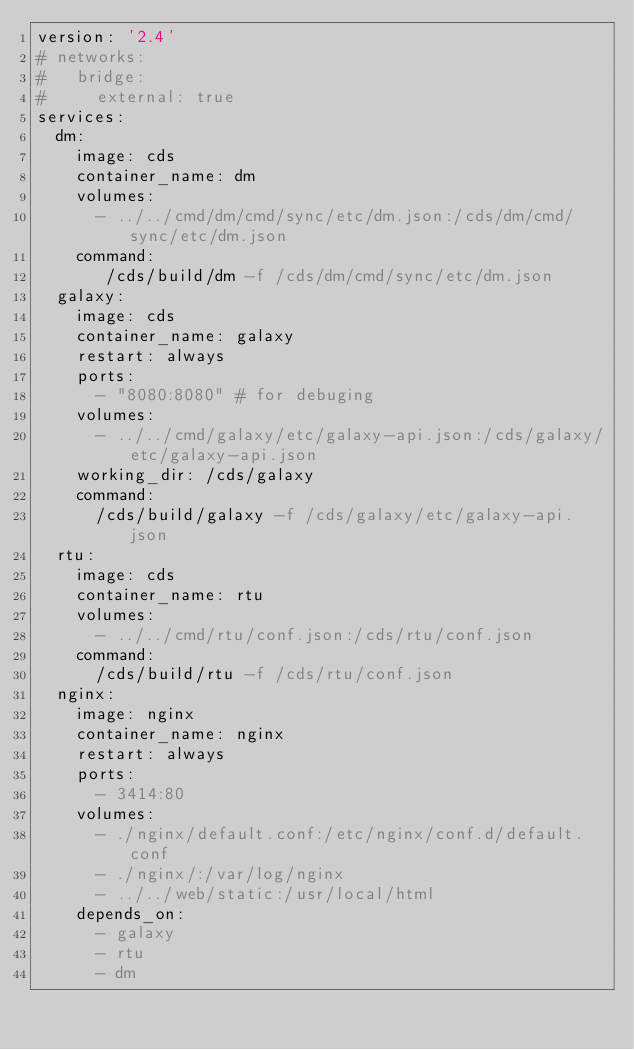Convert code to text. <code><loc_0><loc_0><loc_500><loc_500><_YAML_>version: '2.4'
# networks:
#   bridge:
#     external: true
services:
  dm:
    image: cds
    container_name: dm
    volumes:
      - ../../cmd/dm/cmd/sync/etc/dm.json:/cds/dm/cmd/sync/etc/dm.json
    command:
       /cds/build/dm -f /cds/dm/cmd/sync/etc/dm.json
  galaxy:
    image: cds
    container_name: galaxy
    restart: always
    ports:
      - "8080:8080" # for debuging
    volumes:
      - ../../cmd/galaxy/etc/galaxy-api.json:/cds/galaxy/etc/galaxy-api.json
    working_dir: /cds/galaxy
    command:
      /cds/build/galaxy -f /cds/galaxy/etc/galaxy-api.json
  rtu:
    image: cds
    container_name: rtu
    volumes:
      - ../../cmd/rtu/conf.json:/cds/rtu/conf.json
    command:
      /cds/build/rtu -f /cds/rtu/conf.json
  nginx:
    image: nginx
    container_name: nginx
    restart: always
    ports:
      - 3414:80
    volumes:
      - ./nginx/default.conf:/etc/nginx/conf.d/default.conf
      - ./nginx/:/var/log/nginx
      - ../../web/static:/usr/local/html
    depends_on:
      - galaxy
      - rtu
      - dm </code> 